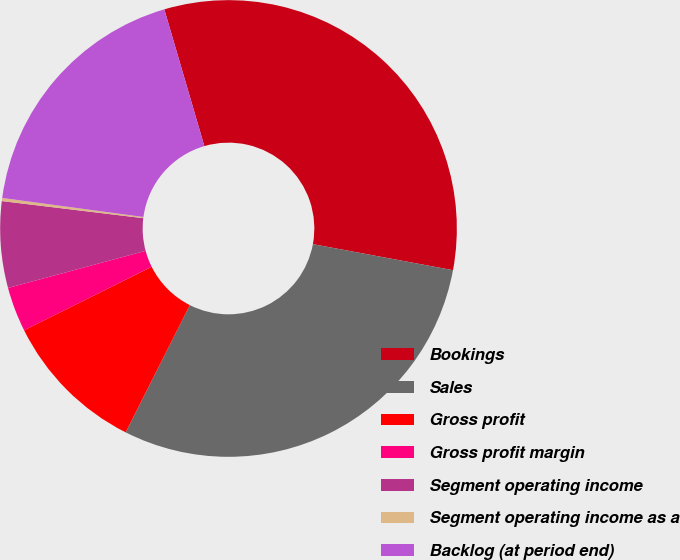Convert chart to OTSL. <chart><loc_0><loc_0><loc_500><loc_500><pie_chart><fcel>Bookings<fcel>Sales<fcel>Gross profit<fcel>Gross profit margin<fcel>Segment operating income<fcel>Segment operating income as a<fcel>Backlog (at period end)<nl><fcel>32.46%<fcel>29.51%<fcel>10.21%<fcel>3.16%<fcel>6.11%<fcel>0.22%<fcel>18.33%<nl></chart> 